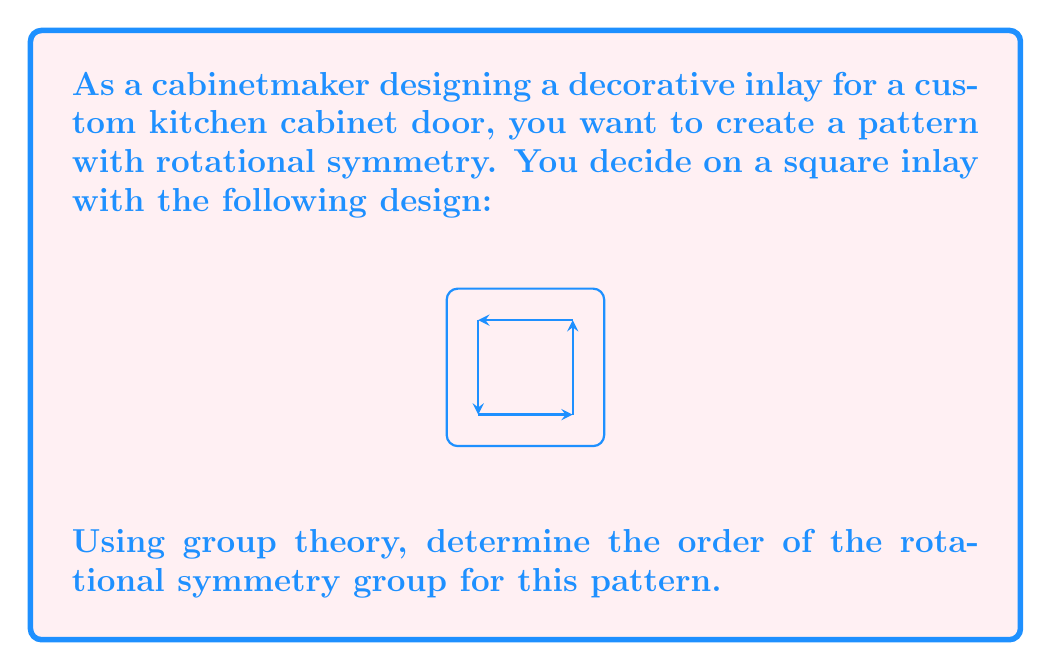Give your solution to this math problem. To solve this problem, we'll follow these steps:

1) First, we need to identify the symmetries of the pattern. The square inlay with arrows forms a cyclic pattern that remains unchanged under certain rotations.

2) In group theory, rotational symmetries form a cyclic group. The order of this group is the number of distinct rotations (including the identity) that leave the pattern unchanged.

3) Let's analyze the rotations:
   - 0° rotation (identity): Always leaves the pattern unchanged.
   - 90° clockwise rotation: Leaves the pattern unchanged.
   - 180° rotation: Leaves the pattern unchanged.
   - 270° clockwise rotation (or 90° counterclockwise): Leaves the pattern unchanged.

4) Any further rotation would repeat one of these positions.

5) Therefore, we have 4 distinct rotations that leave the pattern unchanged: 0°, 90°, 180°, and 270°.

6) In group theory terms, this is the cyclic group $C_4$, which has order 4.

The rotational symmetry group of this pattern is isomorphic to the cyclic group $C_4$, and its order is 4.
Answer: 4 